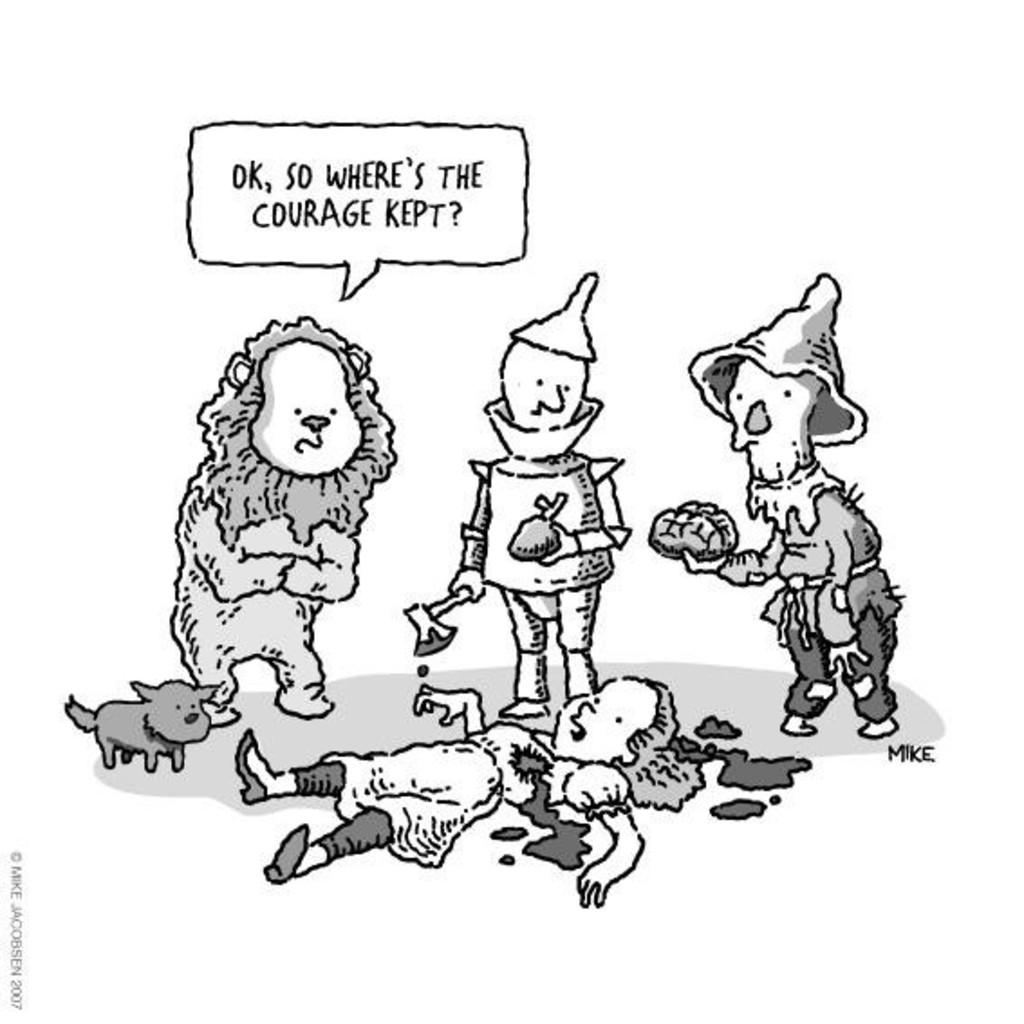What type of images are present in the picture? There are cartoon images in the picture. What are the cartoon images doing? The cartoon images are holding something. What color is the background of the image? The background of the image is white. Is there any text present on the image? Yes, there is text written on the image. Can you tell me how many chin plants are visible in the image? There are no chin plants present in the image. What type of map is shown in the image? There is no map present in the image. 